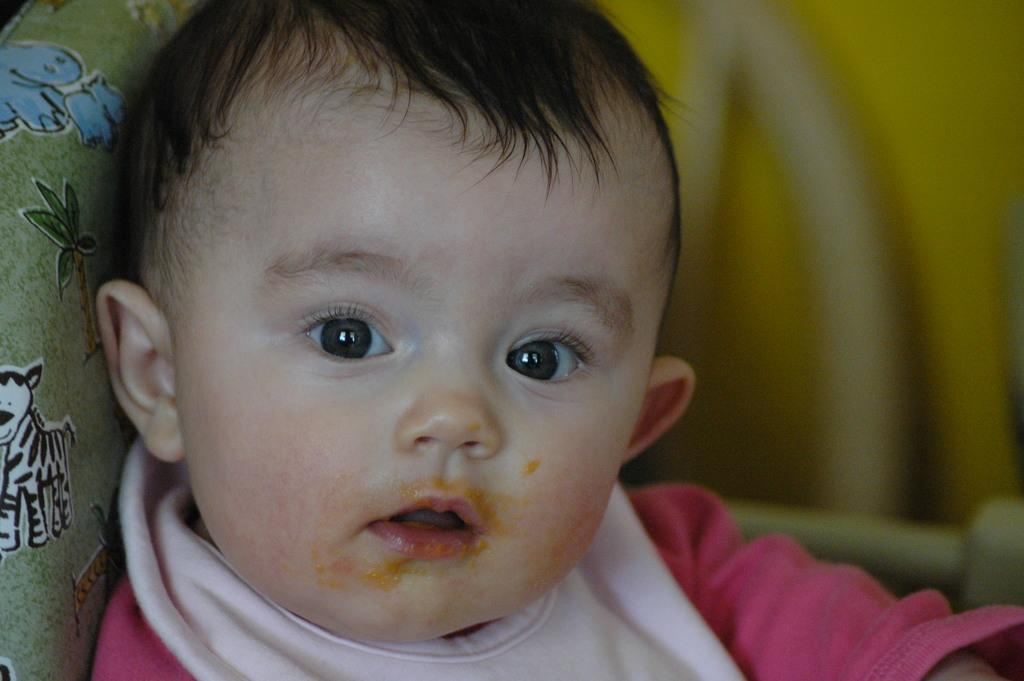Who is the main subject in the picture? There is a boy in the picture. What is the boy doing in the image? The boy is sitting on a couch. What is the boy wearing in the image? The boy is wearing a pink shirt. What can be seen on the left side of the couch? There is a green pillow on the left side of the couch. What can be seen on the top right of the couch? There is a yellow object on the top right of the couch. What letters are the boy spelling out with his knee in the image? There is no indication in the image that the boy is spelling out letters with his knee. 